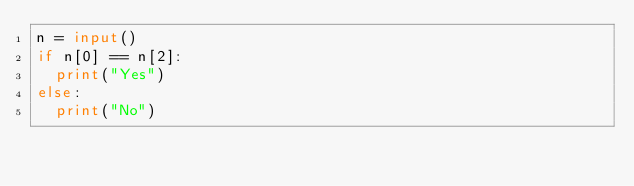<code> <loc_0><loc_0><loc_500><loc_500><_Python_>n = input()
if n[0] == n[2]:
  print("Yes")
else:
  print("No")</code> 